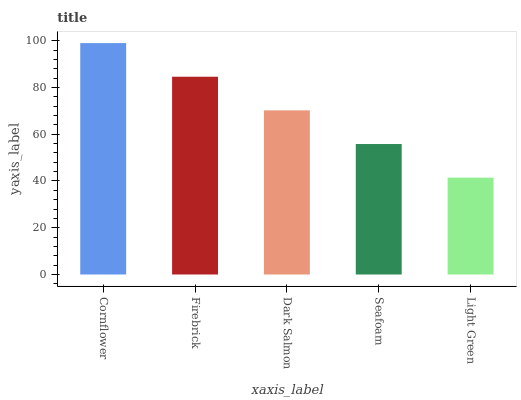Is Light Green the minimum?
Answer yes or no. Yes. Is Cornflower the maximum?
Answer yes or no. Yes. Is Firebrick the minimum?
Answer yes or no. No. Is Firebrick the maximum?
Answer yes or no. No. Is Cornflower greater than Firebrick?
Answer yes or no. Yes. Is Firebrick less than Cornflower?
Answer yes or no. Yes. Is Firebrick greater than Cornflower?
Answer yes or no. No. Is Cornflower less than Firebrick?
Answer yes or no. No. Is Dark Salmon the high median?
Answer yes or no. Yes. Is Dark Salmon the low median?
Answer yes or no. Yes. Is Light Green the high median?
Answer yes or no. No. Is Cornflower the low median?
Answer yes or no. No. 